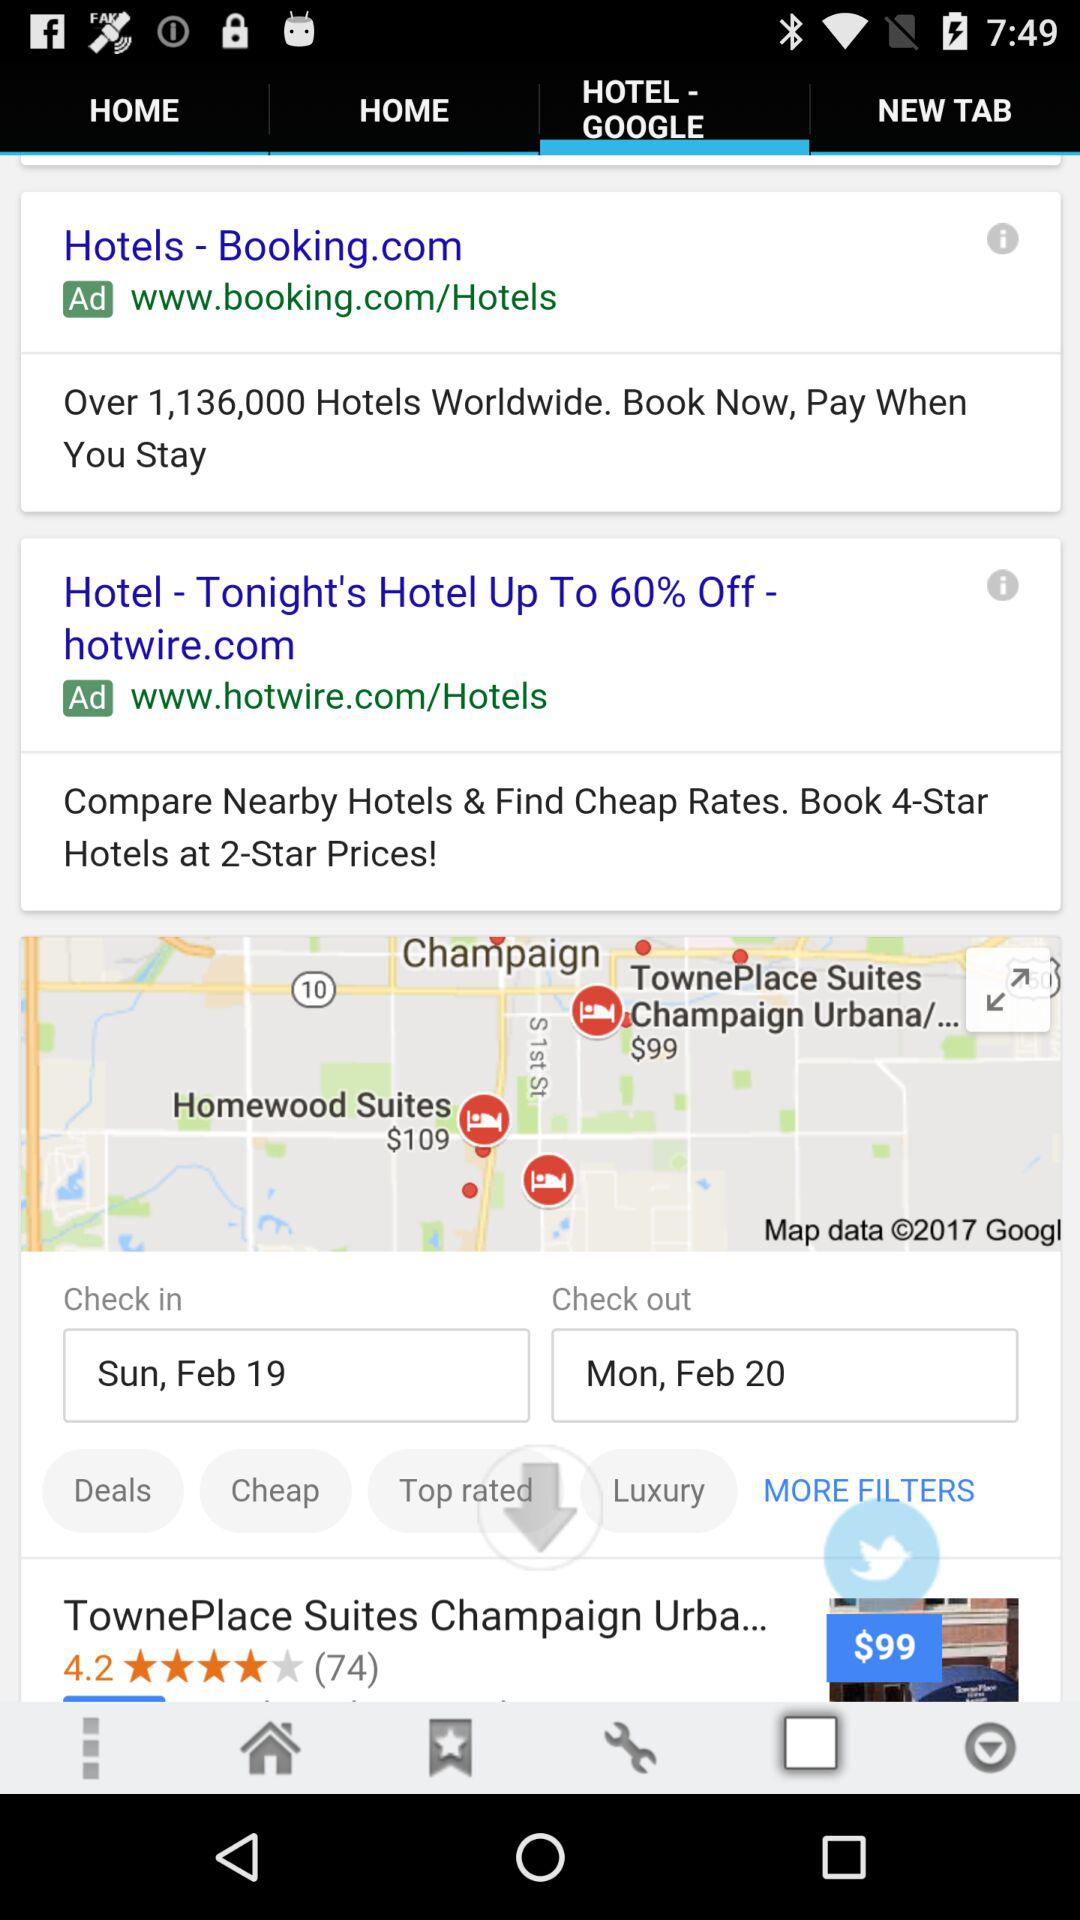What is the check-out date? The check-out date is Monday, February 20. 